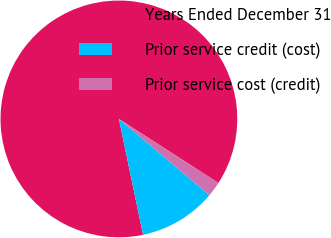Convert chart. <chart><loc_0><loc_0><loc_500><loc_500><pie_chart><fcel>Years Ended December 31<fcel>Prior service credit (cost)<fcel>Prior service cost (credit)<nl><fcel>87.38%<fcel>10.58%<fcel>2.04%<nl></chart> 